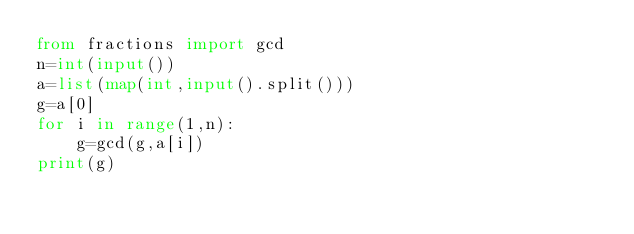<code> <loc_0><loc_0><loc_500><loc_500><_Python_>from fractions import gcd
n=int(input())
a=list(map(int,input().split()))
g=a[0]
for i in range(1,n):
    g=gcd(g,a[i])
print(g)</code> 